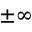<formula> <loc_0><loc_0><loc_500><loc_500>\pm \infty</formula> 